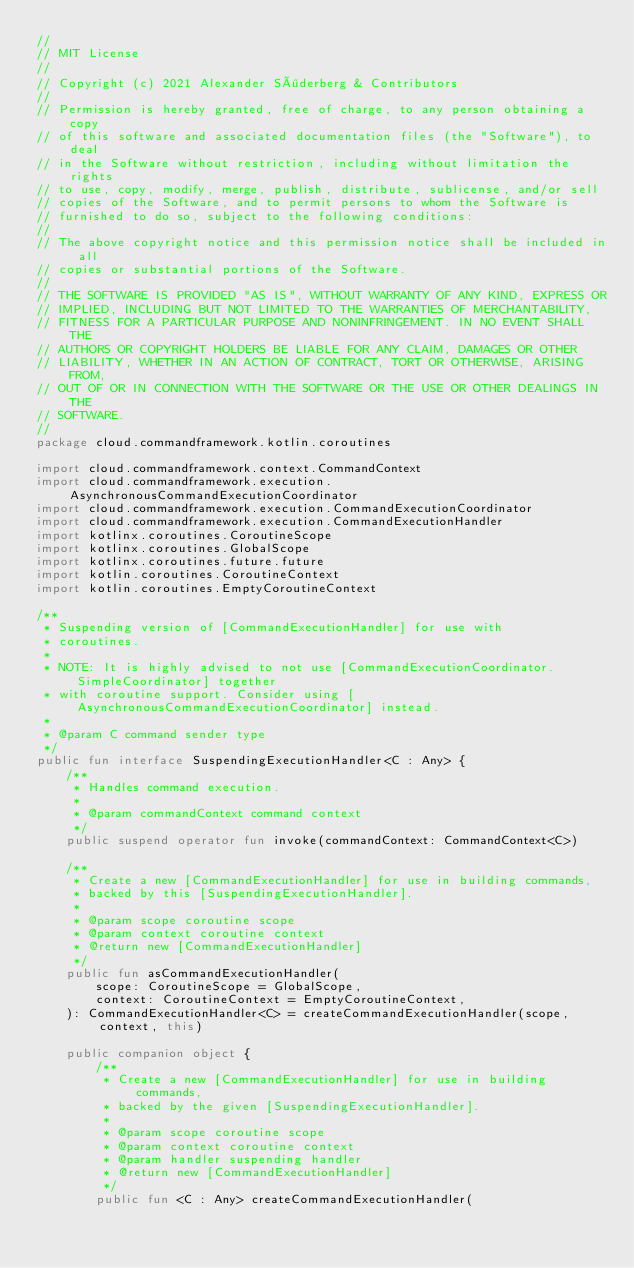<code> <loc_0><loc_0><loc_500><loc_500><_Kotlin_>//
// MIT License
//
// Copyright (c) 2021 Alexander Söderberg & Contributors
//
// Permission is hereby granted, free of charge, to any person obtaining a copy
// of this software and associated documentation files (the "Software"), to deal
// in the Software without restriction, including without limitation the rights
// to use, copy, modify, merge, publish, distribute, sublicense, and/or sell
// copies of the Software, and to permit persons to whom the Software is
// furnished to do so, subject to the following conditions:
//
// The above copyright notice and this permission notice shall be included in all
// copies or substantial portions of the Software.
//
// THE SOFTWARE IS PROVIDED "AS IS", WITHOUT WARRANTY OF ANY KIND, EXPRESS OR
// IMPLIED, INCLUDING BUT NOT LIMITED TO THE WARRANTIES OF MERCHANTABILITY,
// FITNESS FOR A PARTICULAR PURPOSE AND NONINFRINGEMENT. IN NO EVENT SHALL THE
// AUTHORS OR COPYRIGHT HOLDERS BE LIABLE FOR ANY CLAIM, DAMAGES OR OTHER
// LIABILITY, WHETHER IN AN ACTION OF CONTRACT, TORT OR OTHERWISE, ARISING FROM,
// OUT OF OR IN CONNECTION WITH THE SOFTWARE OR THE USE OR OTHER DEALINGS IN THE
// SOFTWARE.
//
package cloud.commandframework.kotlin.coroutines

import cloud.commandframework.context.CommandContext
import cloud.commandframework.execution.AsynchronousCommandExecutionCoordinator
import cloud.commandframework.execution.CommandExecutionCoordinator
import cloud.commandframework.execution.CommandExecutionHandler
import kotlinx.coroutines.CoroutineScope
import kotlinx.coroutines.GlobalScope
import kotlinx.coroutines.future.future
import kotlin.coroutines.CoroutineContext
import kotlin.coroutines.EmptyCoroutineContext

/**
 * Suspending version of [CommandExecutionHandler] for use with
 * coroutines.
 *
 * NOTE: It is highly advised to not use [CommandExecutionCoordinator.SimpleCoordinator] together
 * with coroutine support. Consider using [AsynchronousCommandExecutionCoordinator] instead.
 *
 * @param C command sender type
 */
public fun interface SuspendingExecutionHandler<C : Any> {
    /**
     * Handles command execution.
     *
     * @param commandContext command context
     */
    public suspend operator fun invoke(commandContext: CommandContext<C>)

    /**
     * Create a new [CommandExecutionHandler] for use in building commands,
     * backed by this [SuspendingExecutionHandler].
     *
     * @param scope coroutine scope
     * @param context coroutine context
     * @return new [CommandExecutionHandler]
     */
    public fun asCommandExecutionHandler(
        scope: CoroutineScope = GlobalScope,
        context: CoroutineContext = EmptyCoroutineContext,
    ): CommandExecutionHandler<C> = createCommandExecutionHandler(scope, context, this)

    public companion object {
        /**
         * Create a new [CommandExecutionHandler] for use in building commands,
         * backed by the given [SuspendingExecutionHandler].
         *
         * @param scope coroutine scope
         * @param context coroutine context
         * @param handler suspending handler
         * @return new [CommandExecutionHandler]
         */
        public fun <C : Any> createCommandExecutionHandler(</code> 